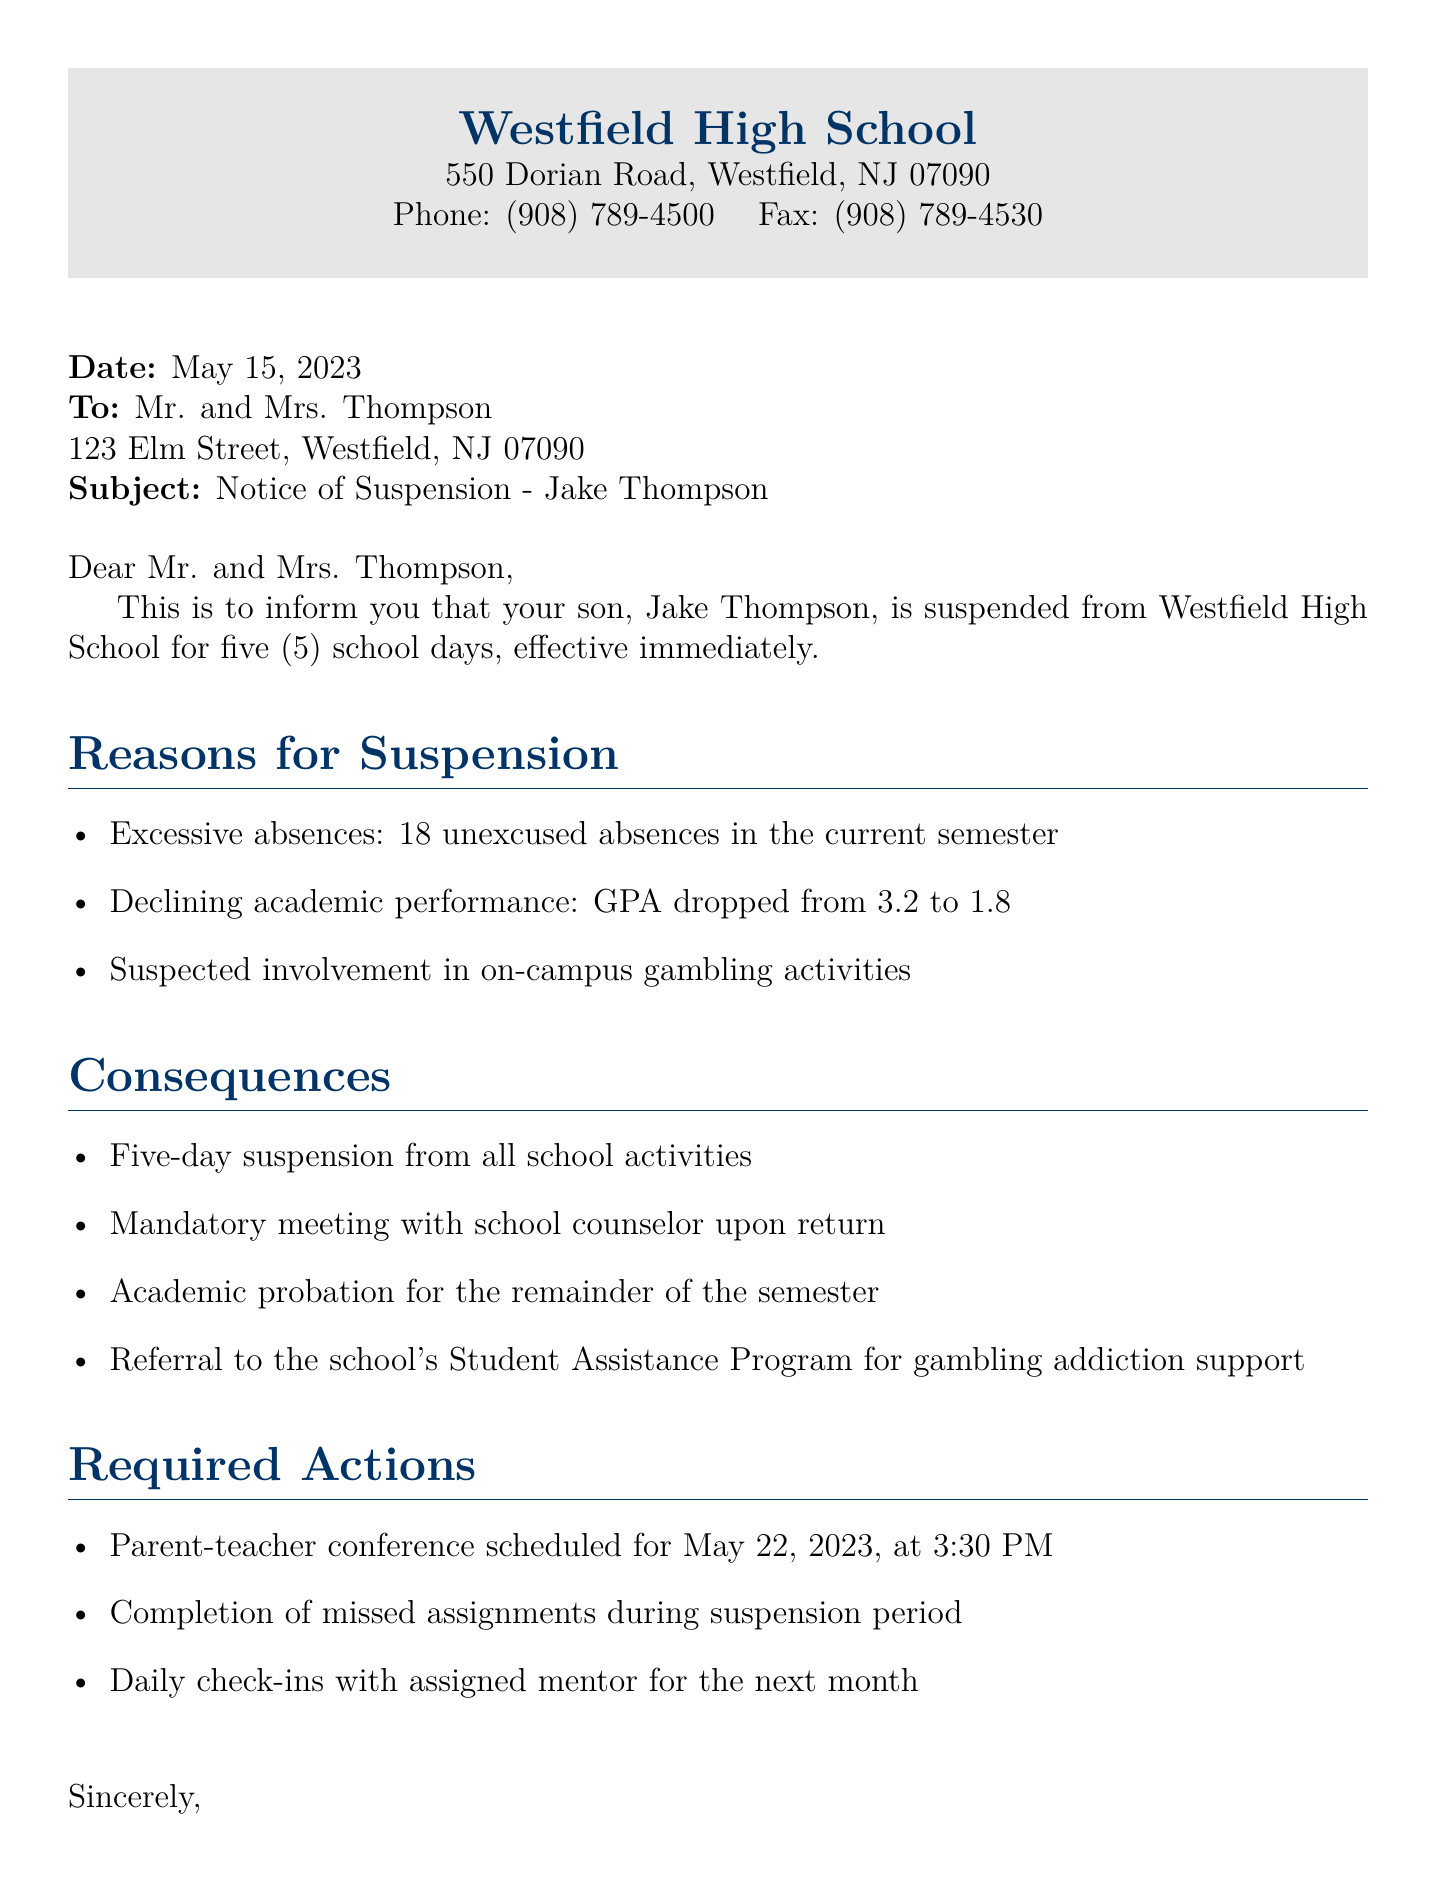What is the name of the school? The name of the school is mentioned at the beginning of the document, which is Westfield High School.
Answer: Westfield High School Who is the principal? The principal's name is provided in the closing section of the document, which is Sarah Johnson.
Answer: Sarah Johnson How many unexcused absences did Jake have? The number of unexcused absences is listed in the reasons for suspension as 18 unexcused absences.
Answer: 18 What is Jake's current GPA? The document states that Jake's GPA dropped from 3.2 to 1.8, so the current GPA is 1.8.
Answer: 1.8 What is the duration of the suspension? The duration of the suspension is explicitly stated in the document as five (5) school days.
Answer: five (5) school days What is required upon Jake's return? The document mentions a mandatory meeting with the school counselor upon Jake's return.
Answer: meeting with school counselor When is the parent-teacher conference scheduled? The scheduling of the parent-teacher conference is noted as May 22, 2023, at 3:30 PM.
Answer: May 22, 2023, at 3:30 PM What program is Jake referred to for support? The document states that Jake is referred to the school's Student Assistance Program for gambling addiction support.
Answer: Student Assistance Program What are the consequences outlined in the document? The consequences include a five-day suspension, mandatory meeting, academic probation, and referral for support.
Answer: Five-day suspension, mandatory meeting, academic probation, referral for support 